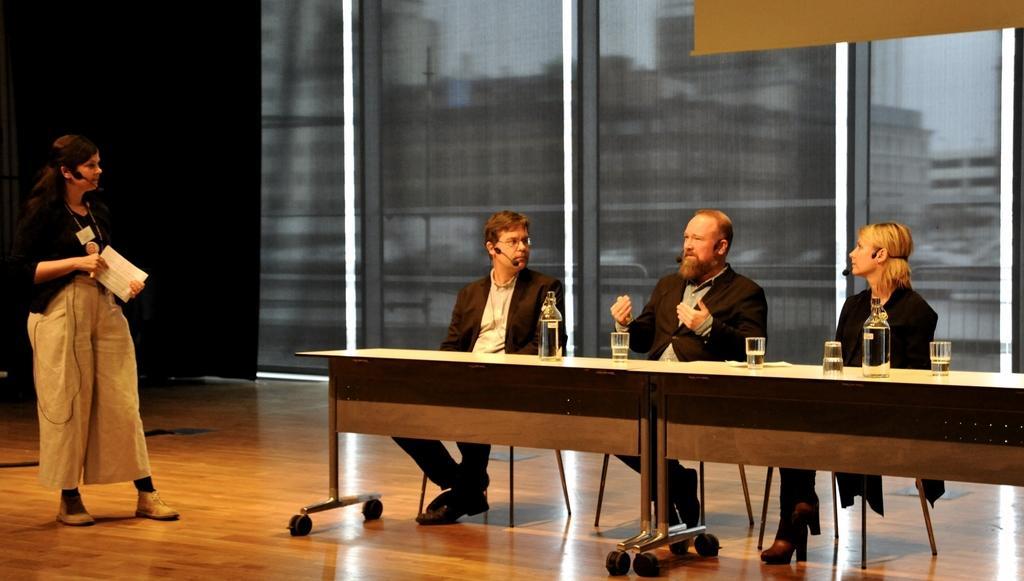Can you describe this image briefly? In this image I can see four people where one is standing and rest are sitting on chairs. Here on this table I can see few bottles and few glasses. I can also see all of them are wearing mics and here I can see she is holding a paper. 